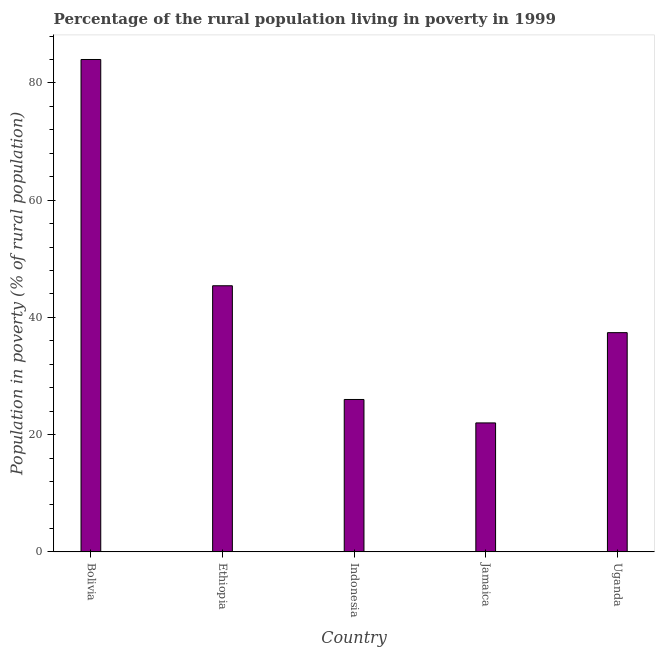Does the graph contain any zero values?
Offer a terse response. No. What is the title of the graph?
Your answer should be compact. Percentage of the rural population living in poverty in 1999. What is the label or title of the Y-axis?
Provide a short and direct response. Population in poverty (% of rural population). What is the percentage of rural population living below poverty line in Bolivia?
Give a very brief answer. 84. Across all countries, what is the minimum percentage of rural population living below poverty line?
Make the answer very short. 22. In which country was the percentage of rural population living below poverty line minimum?
Give a very brief answer. Jamaica. What is the sum of the percentage of rural population living below poverty line?
Offer a terse response. 214.8. What is the difference between the percentage of rural population living below poverty line in Ethiopia and Jamaica?
Your answer should be compact. 23.4. What is the average percentage of rural population living below poverty line per country?
Your answer should be very brief. 42.96. What is the median percentage of rural population living below poverty line?
Your response must be concise. 37.4. What is the ratio of the percentage of rural population living below poverty line in Bolivia to that in Uganda?
Give a very brief answer. 2.25. What is the difference between the highest and the second highest percentage of rural population living below poverty line?
Your response must be concise. 38.6. Is the sum of the percentage of rural population living below poverty line in Ethiopia and Indonesia greater than the maximum percentage of rural population living below poverty line across all countries?
Keep it short and to the point. No. How many bars are there?
Make the answer very short. 5. How many countries are there in the graph?
Your answer should be very brief. 5. What is the difference between two consecutive major ticks on the Y-axis?
Your response must be concise. 20. Are the values on the major ticks of Y-axis written in scientific E-notation?
Make the answer very short. No. What is the Population in poverty (% of rural population) in Bolivia?
Offer a terse response. 84. What is the Population in poverty (% of rural population) of Ethiopia?
Your answer should be very brief. 45.4. What is the Population in poverty (% of rural population) of Indonesia?
Make the answer very short. 26. What is the Population in poverty (% of rural population) of Jamaica?
Keep it short and to the point. 22. What is the Population in poverty (% of rural population) of Uganda?
Provide a short and direct response. 37.4. What is the difference between the Population in poverty (% of rural population) in Bolivia and Ethiopia?
Your response must be concise. 38.6. What is the difference between the Population in poverty (% of rural population) in Bolivia and Indonesia?
Your answer should be very brief. 58. What is the difference between the Population in poverty (% of rural population) in Bolivia and Uganda?
Your response must be concise. 46.6. What is the difference between the Population in poverty (% of rural population) in Ethiopia and Jamaica?
Offer a very short reply. 23.4. What is the difference between the Population in poverty (% of rural population) in Ethiopia and Uganda?
Make the answer very short. 8. What is the difference between the Population in poverty (% of rural population) in Indonesia and Jamaica?
Ensure brevity in your answer.  4. What is the difference between the Population in poverty (% of rural population) in Indonesia and Uganda?
Your answer should be compact. -11.4. What is the difference between the Population in poverty (% of rural population) in Jamaica and Uganda?
Ensure brevity in your answer.  -15.4. What is the ratio of the Population in poverty (% of rural population) in Bolivia to that in Ethiopia?
Make the answer very short. 1.85. What is the ratio of the Population in poverty (% of rural population) in Bolivia to that in Indonesia?
Offer a very short reply. 3.23. What is the ratio of the Population in poverty (% of rural population) in Bolivia to that in Jamaica?
Ensure brevity in your answer.  3.82. What is the ratio of the Population in poverty (% of rural population) in Bolivia to that in Uganda?
Make the answer very short. 2.25. What is the ratio of the Population in poverty (% of rural population) in Ethiopia to that in Indonesia?
Give a very brief answer. 1.75. What is the ratio of the Population in poverty (% of rural population) in Ethiopia to that in Jamaica?
Ensure brevity in your answer.  2.06. What is the ratio of the Population in poverty (% of rural population) in Ethiopia to that in Uganda?
Your answer should be compact. 1.21. What is the ratio of the Population in poverty (% of rural population) in Indonesia to that in Jamaica?
Your answer should be compact. 1.18. What is the ratio of the Population in poverty (% of rural population) in Indonesia to that in Uganda?
Your answer should be compact. 0.69. What is the ratio of the Population in poverty (% of rural population) in Jamaica to that in Uganda?
Provide a short and direct response. 0.59. 